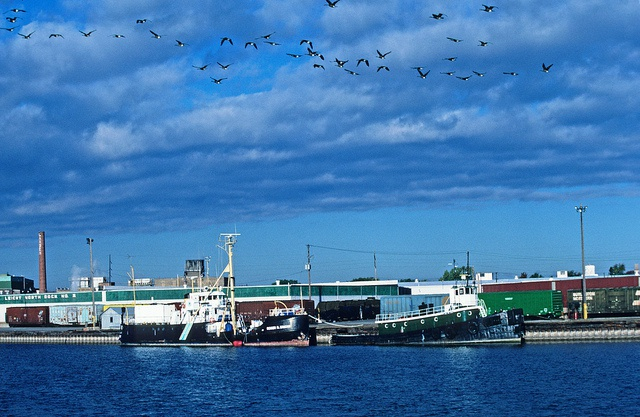Describe the objects in this image and their specific colors. I can see bird in blue and gray tones, boat in blue, black, white, gray, and darkgray tones, boat in blue, black, navy, and gray tones, boat in blue, black, lightgray, gray, and darkgray tones, and boat in blue, black, teal, and white tones in this image. 